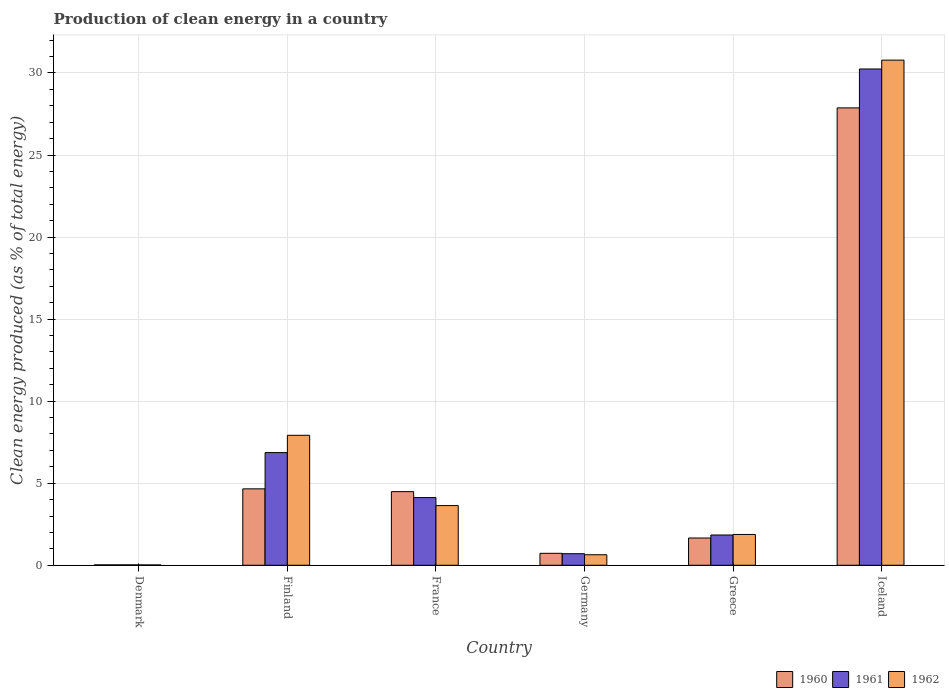How many bars are there on the 4th tick from the right?
Provide a short and direct response. 3. In how many cases, is the number of bars for a given country not equal to the number of legend labels?
Your response must be concise. 0. What is the percentage of clean energy produced in 1961 in Finland?
Offer a very short reply. 6.87. Across all countries, what is the maximum percentage of clean energy produced in 1962?
Provide a succinct answer. 30.78. Across all countries, what is the minimum percentage of clean energy produced in 1962?
Your answer should be very brief. 0.02. In which country was the percentage of clean energy produced in 1962 maximum?
Provide a short and direct response. Iceland. In which country was the percentage of clean energy produced in 1961 minimum?
Your answer should be compact. Denmark. What is the total percentage of clean energy produced in 1960 in the graph?
Your answer should be compact. 39.43. What is the difference between the percentage of clean energy produced in 1962 in Denmark and that in Iceland?
Make the answer very short. -30.76. What is the difference between the percentage of clean energy produced in 1962 in Iceland and the percentage of clean energy produced in 1961 in Finland?
Provide a succinct answer. 23.92. What is the average percentage of clean energy produced in 1960 per country?
Offer a very short reply. 6.57. What is the difference between the percentage of clean energy produced of/in 1962 and percentage of clean energy produced of/in 1960 in Iceland?
Make the answer very short. 2.91. What is the ratio of the percentage of clean energy produced in 1961 in Greece to that in Iceland?
Your response must be concise. 0.06. What is the difference between the highest and the second highest percentage of clean energy produced in 1961?
Your response must be concise. -26.12. What is the difference between the highest and the lowest percentage of clean energy produced in 1961?
Provide a succinct answer. 30.22. In how many countries, is the percentage of clean energy produced in 1962 greater than the average percentage of clean energy produced in 1962 taken over all countries?
Give a very brief answer. 2. Is the sum of the percentage of clean energy produced in 1962 in Denmark and France greater than the maximum percentage of clean energy produced in 1961 across all countries?
Ensure brevity in your answer.  No. What does the 2nd bar from the left in Germany represents?
Keep it short and to the point. 1961. What does the 1st bar from the right in Iceland represents?
Make the answer very short. 1962. Is it the case that in every country, the sum of the percentage of clean energy produced in 1961 and percentage of clean energy produced in 1962 is greater than the percentage of clean energy produced in 1960?
Give a very brief answer. Yes. Are all the bars in the graph horizontal?
Offer a very short reply. No. How many countries are there in the graph?
Give a very brief answer. 6. Does the graph contain any zero values?
Your answer should be very brief. No. Where does the legend appear in the graph?
Offer a terse response. Bottom right. How are the legend labels stacked?
Offer a very short reply. Horizontal. What is the title of the graph?
Make the answer very short. Production of clean energy in a country. Does "2014" appear as one of the legend labels in the graph?
Ensure brevity in your answer.  No. What is the label or title of the X-axis?
Offer a terse response. Country. What is the label or title of the Y-axis?
Your response must be concise. Clean energy produced (as % of total energy). What is the Clean energy produced (as % of total energy) in 1960 in Denmark?
Your answer should be compact. 0.02. What is the Clean energy produced (as % of total energy) in 1961 in Denmark?
Offer a terse response. 0.02. What is the Clean energy produced (as % of total energy) in 1962 in Denmark?
Your answer should be very brief. 0.02. What is the Clean energy produced (as % of total energy) of 1960 in Finland?
Offer a terse response. 4.66. What is the Clean energy produced (as % of total energy) in 1961 in Finland?
Ensure brevity in your answer.  6.87. What is the Clean energy produced (as % of total energy) in 1962 in Finland?
Offer a terse response. 7.92. What is the Clean energy produced (as % of total energy) in 1960 in France?
Ensure brevity in your answer.  4.49. What is the Clean energy produced (as % of total energy) in 1961 in France?
Keep it short and to the point. 4.12. What is the Clean energy produced (as % of total energy) in 1962 in France?
Your answer should be compact. 3.64. What is the Clean energy produced (as % of total energy) of 1960 in Germany?
Offer a very short reply. 0.73. What is the Clean energy produced (as % of total energy) in 1961 in Germany?
Your answer should be compact. 0.7. What is the Clean energy produced (as % of total energy) in 1962 in Germany?
Keep it short and to the point. 0.64. What is the Clean energy produced (as % of total energy) of 1960 in Greece?
Provide a short and direct response. 1.66. What is the Clean energy produced (as % of total energy) in 1961 in Greece?
Your response must be concise. 1.84. What is the Clean energy produced (as % of total energy) in 1962 in Greece?
Provide a short and direct response. 1.88. What is the Clean energy produced (as % of total energy) of 1960 in Iceland?
Provide a succinct answer. 27.87. What is the Clean energy produced (as % of total energy) in 1961 in Iceland?
Offer a very short reply. 30.24. What is the Clean energy produced (as % of total energy) of 1962 in Iceland?
Offer a very short reply. 30.78. Across all countries, what is the maximum Clean energy produced (as % of total energy) of 1960?
Offer a very short reply. 27.87. Across all countries, what is the maximum Clean energy produced (as % of total energy) in 1961?
Make the answer very short. 30.24. Across all countries, what is the maximum Clean energy produced (as % of total energy) of 1962?
Make the answer very short. 30.78. Across all countries, what is the minimum Clean energy produced (as % of total energy) in 1960?
Give a very brief answer. 0.02. Across all countries, what is the minimum Clean energy produced (as % of total energy) in 1961?
Your answer should be very brief. 0.02. Across all countries, what is the minimum Clean energy produced (as % of total energy) in 1962?
Provide a succinct answer. 0.02. What is the total Clean energy produced (as % of total energy) of 1960 in the graph?
Offer a terse response. 39.43. What is the total Clean energy produced (as % of total energy) in 1961 in the graph?
Offer a very short reply. 43.81. What is the total Clean energy produced (as % of total energy) in 1962 in the graph?
Your response must be concise. 44.88. What is the difference between the Clean energy produced (as % of total energy) in 1960 in Denmark and that in Finland?
Make the answer very short. -4.63. What is the difference between the Clean energy produced (as % of total energy) in 1961 in Denmark and that in Finland?
Your answer should be compact. -6.84. What is the difference between the Clean energy produced (as % of total energy) in 1962 in Denmark and that in Finland?
Provide a short and direct response. -7.9. What is the difference between the Clean energy produced (as % of total energy) in 1960 in Denmark and that in France?
Ensure brevity in your answer.  -4.46. What is the difference between the Clean energy produced (as % of total energy) of 1961 in Denmark and that in France?
Offer a very short reply. -4.1. What is the difference between the Clean energy produced (as % of total energy) of 1962 in Denmark and that in France?
Give a very brief answer. -3.62. What is the difference between the Clean energy produced (as % of total energy) in 1960 in Denmark and that in Germany?
Make the answer very short. -0.7. What is the difference between the Clean energy produced (as % of total energy) in 1961 in Denmark and that in Germany?
Your response must be concise. -0.68. What is the difference between the Clean energy produced (as % of total energy) in 1962 in Denmark and that in Germany?
Provide a short and direct response. -0.62. What is the difference between the Clean energy produced (as % of total energy) of 1960 in Denmark and that in Greece?
Provide a succinct answer. -1.64. What is the difference between the Clean energy produced (as % of total energy) of 1961 in Denmark and that in Greece?
Give a very brief answer. -1.82. What is the difference between the Clean energy produced (as % of total energy) of 1962 in Denmark and that in Greece?
Provide a succinct answer. -1.86. What is the difference between the Clean energy produced (as % of total energy) of 1960 in Denmark and that in Iceland?
Provide a succinct answer. -27.85. What is the difference between the Clean energy produced (as % of total energy) of 1961 in Denmark and that in Iceland?
Your answer should be compact. -30.22. What is the difference between the Clean energy produced (as % of total energy) in 1962 in Denmark and that in Iceland?
Give a very brief answer. -30.76. What is the difference between the Clean energy produced (as % of total energy) of 1960 in Finland and that in France?
Your response must be concise. 0.17. What is the difference between the Clean energy produced (as % of total energy) in 1961 in Finland and that in France?
Ensure brevity in your answer.  2.74. What is the difference between the Clean energy produced (as % of total energy) of 1962 in Finland and that in France?
Give a very brief answer. 4.28. What is the difference between the Clean energy produced (as % of total energy) of 1960 in Finland and that in Germany?
Provide a short and direct response. 3.93. What is the difference between the Clean energy produced (as % of total energy) of 1961 in Finland and that in Germany?
Provide a short and direct response. 6.16. What is the difference between the Clean energy produced (as % of total energy) of 1962 in Finland and that in Germany?
Keep it short and to the point. 7.28. What is the difference between the Clean energy produced (as % of total energy) of 1960 in Finland and that in Greece?
Ensure brevity in your answer.  3. What is the difference between the Clean energy produced (as % of total energy) in 1961 in Finland and that in Greece?
Offer a terse response. 5.02. What is the difference between the Clean energy produced (as % of total energy) of 1962 in Finland and that in Greece?
Make the answer very short. 6.04. What is the difference between the Clean energy produced (as % of total energy) of 1960 in Finland and that in Iceland?
Ensure brevity in your answer.  -23.22. What is the difference between the Clean energy produced (as % of total energy) in 1961 in Finland and that in Iceland?
Offer a terse response. -23.38. What is the difference between the Clean energy produced (as % of total energy) of 1962 in Finland and that in Iceland?
Keep it short and to the point. -22.86. What is the difference between the Clean energy produced (as % of total energy) of 1960 in France and that in Germany?
Provide a succinct answer. 3.76. What is the difference between the Clean energy produced (as % of total energy) in 1961 in France and that in Germany?
Your answer should be compact. 3.42. What is the difference between the Clean energy produced (as % of total energy) in 1962 in France and that in Germany?
Your response must be concise. 3. What is the difference between the Clean energy produced (as % of total energy) of 1960 in France and that in Greece?
Offer a terse response. 2.83. What is the difference between the Clean energy produced (as % of total energy) of 1961 in France and that in Greece?
Your answer should be compact. 2.28. What is the difference between the Clean energy produced (as % of total energy) in 1962 in France and that in Greece?
Make the answer very short. 1.76. What is the difference between the Clean energy produced (as % of total energy) of 1960 in France and that in Iceland?
Make the answer very short. -23.39. What is the difference between the Clean energy produced (as % of total energy) in 1961 in France and that in Iceland?
Offer a very short reply. -26.12. What is the difference between the Clean energy produced (as % of total energy) in 1962 in France and that in Iceland?
Ensure brevity in your answer.  -27.15. What is the difference between the Clean energy produced (as % of total energy) in 1960 in Germany and that in Greece?
Your answer should be compact. -0.93. What is the difference between the Clean energy produced (as % of total energy) of 1961 in Germany and that in Greece?
Your answer should be compact. -1.14. What is the difference between the Clean energy produced (as % of total energy) in 1962 in Germany and that in Greece?
Offer a terse response. -1.24. What is the difference between the Clean energy produced (as % of total energy) of 1960 in Germany and that in Iceland?
Your answer should be very brief. -27.14. What is the difference between the Clean energy produced (as % of total energy) of 1961 in Germany and that in Iceland?
Your answer should be very brief. -29.54. What is the difference between the Clean energy produced (as % of total energy) of 1962 in Germany and that in Iceland?
Make the answer very short. -30.14. What is the difference between the Clean energy produced (as % of total energy) in 1960 in Greece and that in Iceland?
Provide a short and direct response. -26.21. What is the difference between the Clean energy produced (as % of total energy) of 1961 in Greece and that in Iceland?
Offer a terse response. -28.4. What is the difference between the Clean energy produced (as % of total energy) of 1962 in Greece and that in Iceland?
Ensure brevity in your answer.  -28.9. What is the difference between the Clean energy produced (as % of total energy) in 1960 in Denmark and the Clean energy produced (as % of total energy) in 1961 in Finland?
Your answer should be very brief. -6.84. What is the difference between the Clean energy produced (as % of total energy) in 1960 in Denmark and the Clean energy produced (as % of total energy) in 1962 in Finland?
Provide a short and direct response. -7.9. What is the difference between the Clean energy produced (as % of total energy) in 1961 in Denmark and the Clean energy produced (as % of total energy) in 1962 in Finland?
Your answer should be very brief. -7.9. What is the difference between the Clean energy produced (as % of total energy) in 1960 in Denmark and the Clean energy produced (as % of total energy) in 1962 in France?
Your answer should be compact. -3.61. What is the difference between the Clean energy produced (as % of total energy) of 1961 in Denmark and the Clean energy produced (as % of total energy) of 1962 in France?
Offer a terse response. -3.61. What is the difference between the Clean energy produced (as % of total energy) in 1960 in Denmark and the Clean energy produced (as % of total energy) in 1961 in Germany?
Ensure brevity in your answer.  -0.68. What is the difference between the Clean energy produced (as % of total energy) of 1960 in Denmark and the Clean energy produced (as % of total energy) of 1962 in Germany?
Your response must be concise. -0.62. What is the difference between the Clean energy produced (as % of total energy) of 1961 in Denmark and the Clean energy produced (as % of total energy) of 1962 in Germany?
Provide a short and direct response. -0.62. What is the difference between the Clean energy produced (as % of total energy) in 1960 in Denmark and the Clean energy produced (as % of total energy) in 1961 in Greece?
Offer a very short reply. -1.82. What is the difference between the Clean energy produced (as % of total energy) in 1960 in Denmark and the Clean energy produced (as % of total energy) in 1962 in Greece?
Offer a terse response. -1.85. What is the difference between the Clean energy produced (as % of total energy) in 1961 in Denmark and the Clean energy produced (as % of total energy) in 1962 in Greece?
Offer a terse response. -1.85. What is the difference between the Clean energy produced (as % of total energy) of 1960 in Denmark and the Clean energy produced (as % of total energy) of 1961 in Iceland?
Provide a succinct answer. -30.22. What is the difference between the Clean energy produced (as % of total energy) in 1960 in Denmark and the Clean energy produced (as % of total energy) in 1962 in Iceland?
Your answer should be compact. -30.76. What is the difference between the Clean energy produced (as % of total energy) in 1961 in Denmark and the Clean energy produced (as % of total energy) in 1962 in Iceland?
Your response must be concise. -30.76. What is the difference between the Clean energy produced (as % of total energy) in 1960 in Finland and the Clean energy produced (as % of total energy) in 1961 in France?
Offer a very short reply. 0.53. What is the difference between the Clean energy produced (as % of total energy) in 1960 in Finland and the Clean energy produced (as % of total energy) in 1962 in France?
Give a very brief answer. 1.02. What is the difference between the Clean energy produced (as % of total energy) in 1961 in Finland and the Clean energy produced (as % of total energy) in 1962 in France?
Ensure brevity in your answer.  3.23. What is the difference between the Clean energy produced (as % of total energy) in 1960 in Finland and the Clean energy produced (as % of total energy) in 1961 in Germany?
Your answer should be compact. 3.95. What is the difference between the Clean energy produced (as % of total energy) in 1960 in Finland and the Clean energy produced (as % of total energy) in 1962 in Germany?
Offer a terse response. 4.02. What is the difference between the Clean energy produced (as % of total energy) in 1961 in Finland and the Clean energy produced (as % of total energy) in 1962 in Germany?
Your answer should be compact. 6.23. What is the difference between the Clean energy produced (as % of total energy) in 1960 in Finland and the Clean energy produced (as % of total energy) in 1961 in Greece?
Provide a succinct answer. 2.81. What is the difference between the Clean energy produced (as % of total energy) in 1960 in Finland and the Clean energy produced (as % of total energy) in 1962 in Greece?
Give a very brief answer. 2.78. What is the difference between the Clean energy produced (as % of total energy) in 1961 in Finland and the Clean energy produced (as % of total energy) in 1962 in Greece?
Your answer should be compact. 4.99. What is the difference between the Clean energy produced (as % of total energy) in 1960 in Finland and the Clean energy produced (as % of total energy) in 1961 in Iceland?
Provide a succinct answer. -25.59. What is the difference between the Clean energy produced (as % of total energy) of 1960 in Finland and the Clean energy produced (as % of total energy) of 1962 in Iceland?
Make the answer very short. -26.13. What is the difference between the Clean energy produced (as % of total energy) of 1961 in Finland and the Clean energy produced (as % of total energy) of 1962 in Iceland?
Give a very brief answer. -23.92. What is the difference between the Clean energy produced (as % of total energy) of 1960 in France and the Clean energy produced (as % of total energy) of 1961 in Germany?
Offer a terse response. 3.78. What is the difference between the Clean energy produced (as % of total energy) of 1960 in France and the Clean energy produced (as % of total energy) of 1962 in Germany?
Give a very brief answer. 3.85. What is the difference between the Clean energy produced (as % of total energy) of 1961 in France and the Clean energy produced (as % of total energy) of 1962 in Germany?
Offer a very short reply. 3.48. What is the difference between the Clean energy produced (as % of total energy) in 1960 in France and the Clean energy produced (as % of total energy) in 1961 in Greece?
Give a very brief answer. 2.64. What is the difference between the Clean energy produced (as % of total energy) in 1960 in France and the Clean energy produced (as % of total energy) in 1962 in Greece?
Provide a short and direct response. 2.61. What is the difference between the Clean energy produced (as % of total energy) in 1961 in France and the Clean energy produced (as % of total energy) in 1962 in Greece?
Your answer should be very brief. 2.25. What is the difference between the Clean energy produced (as % of total energy) in 1960 in France and the Clean energy produced (as % of total energy) in 1961 in Iceland?
Provide a succinct answer. -25.76. What is the difference between the Clean energy produced (as % of total energy) of 1960 in France and the Clean energy produced (as % of total energy) of 1962 in Iceland?
Provide a succinct answer. -26.3. What is the difference between the Clean energy produced (as % of total energy) of 1961 in France and the Clean energy produced (as % of total energy) of 1962 in Iceland?
Provide a succinct answer. -26.66. What is the difference between the Clean energy produced (as % of total energy) of 1960 in Germany and the Clean energy produced (as % of total energy) of 1961 in Greece?
Your answer should be compact. -1.12. What is the difference between the Clean energy produced (as % of total energy) of 1960 in Germany and the Clean energy produced (as % of total energy) of 1962 in Greece?
Your answer should be very brief. -1.15. What is the difference between the Clean energy produced (as % of total energy) of 1961 in Germany and the Clean energy produced (as % of total energy) of 1962 in Greece?
Ensure brevity in your answer.  -1.17. What is the difference between the Clean energy produced (as % of total energy) of 1960 in Germany and the Clean energy produced (as % of total energy) of 1961 in Iceland?
Offer a very short reply. -29.52. What is the difference between the Clean energy produced (as % of total energy) in 1960 in Germany and the Clean energy produced (as % of total energy) in 1962 in Iceland?
Your response must be concise. -30.05. What is the difference between the Clean energy produced (as % of total energy) of 1961 in Germany and the Clean energy produced (as % of total energy) of 1962 in Iceland?
Keep it short and to the point. -30.08. What is the difference between the Clean energy produced (as % of total energy) of 1960 in Greece and the Clean energy produced (as % of total energy) of 1961 in Iceland?
Ensure brevity in your answer.  -28.58. What is the difference between the Clean energy produced (as % of total energy) in 1960 in Greece and the Clean energy produced (as % of total energy) in 1962 in Iceland?
Provide a short and direct response. -29.12. What is the difference between the Clean energy produced (as % of total energy) in 1961 in Greece and the Clean energy produced (as % of total energy) in 1962 in Iceland?
Your answer should be compact. -28.94. What is the average Clean energy produced (as % of total energy) in 1960 per country?
Make the answer very short. 6.57. What is the average Clean energy produced (as % of total energy) in 1961 per country?
Provide a short and direct response. 7.3. What is the average Clean energy produced (as % of total energy) in 1962 per country?
Keep it short and to the point. 7.48. What is the difference between the Clean energy produced (as % of total energy) of 1960 and Clean energy produced (as % of total energy) of 1962 in Denmark?
Give a very brief answer. 0. What is the difference between the Clean energy produced (as % of total energy) of 1961 and Clean energy produced (as % of total energy) of 1962 in Denmark?
Give a very brief answer. 0. What is the difference between the Clean energy produced (as % of total energy) of 1960 and Clean energy produced (as % of total energy) of 1961 in Finland?
Keep it short and to the point. -2.21. What is the difference between the Clean energy produced (as % of total energy) in 1960 and Clean energy produced (as % of total energy) in 1962 in Finland?
Offer a terse response. -3.26. What is the difference between the Clean energy produced (as % of total energy) in 1961 and Clean energy produced (as % of total energy) in 1962 in Finland?
Keep it short and to the point. -1.06. What is the difference between the Clean energy produced (as % of total energy) of 1960 and Clean energy produced (as % of total energy) of 1961 in France?
Make the answer very short. 0.36. What is the difference between the Clean energy produced (as % of total energy) of 1960 and Clean energy produced (as % of total energy) of 1962 in France?
Offer a terse response. 0.85. What is the difference between the Clean energy produced (as % of total energy) in 1961 and Clean energy produced (as % of total energy) in 1962 in France?
Your answer should be very brief. 0.49. What is the difference between the Clean energy produced (as % of total energy) in 1960 and Clean energy produced (as % of total energy) in 1961 in Germany?
Your answer should be compact. 0.02. What is the difference between the Clean energy produced (as % of total energy) of 1960 and Clean energy produced (as % of total energy) of 1962 in Germany?
Your answer should be very brief. 0.09. What is the difference between the Clean energy produced (as % of total energy) in 1961 and Clean energy produced (as % of total energy) in 1962 in Germany?
Offer a terse response. 0.06. What is the difference between the Clean energy produced (as % of total energy) of 1960 and Clean energy produced (as % of total energy) of 1961 in Greece?
Offer a terse response. -0.18. What is the difference between the Clean energy produced (as % of total energy) of 1960 and Clean energy produced (as % of total energy) of 1962 in Greece?
Give a very brief answer. -0.22. What is the difference between the Clean energy produced (as % of total energy) of 1961 and Clean energy produced (as % of total energy) of 1962 in Greece?
Offer a very short reply. -0.03. What is the difference between the Clean energy produced (as % of total energy) in 1960 and Clean energy produced (as % of total energy) in 1961 in Iceland?
Ensure brevity in your answer.  -2.37. What is the difference between the Clean energy produced (as % of total energy) of 1960 and Clean energy produced (as % of total energy) of 1962 in Iceland?
Offer a very short reply. -2.91. What is the difference between the Clean energy produced (as % of total energy) of 1961 and Clean energy produced (as % of total energy) of 1962 in Iceland?
Provide a succinct answer. -0.54. What is the ratio of the Clean energy produced (as % of total energy) of 1960 in Denmark to that in Finland?
Offer a very short reply. 0.01. What is the ratio of the Clean energy produced (as % of total energy) of 1961 in Denmark to that in Finland?
Ensure brevity in your answer.  0. What is the ratio of the Clean energy produced (as % of total energy) of 1962 in Denmark to that in Finland?
Your answer should be very brief. 0. What is the ratio of the Clean energy produced (as % of total energy) in 1960 in Denmark to that in France?
Provide a short and direct response. 0.01. What is the ratio of the Clean energy produced (as % of total energy) in 1961 in Denmark to that in France?
Ensure brevity in your answer.  0.01. What is the ratio of the Clean energy produced (as % of total energy) in 1962 in Denmark to that in France?
Provide a succinct answer. 0.01. What is the ratio of the Clean energy produced (as % of total energy) of 1960 in Denmark to that in Germany?
Your answer should be very brief. 0.03. What is the ratio of the Clean energy produced (as % of total energy) of 1961 in Denmark to that in Germany?
Give a very brief answer. 0.03. What is the ratio of the Clean energy produced (as % of total energy) of 1962 in Denmark to that in Germany?
Your answer should be compact. 0.03. What is the ratio of the Clean energy produced (as % of total energy) of 1960 in Denmark to that in Greece?
Keep it short and to the point. 0.01. What is the ratio of the Clean energy produced (as % of total energy) of 1961 in Denmark to that in Greece?
Keep it short and to the point. 0.01. What is the ratio of the Clean energy produced (as % of total energy) in 1962 in Denmark to that in Greece?
Keep it short and to the point. 0.01. What is the ratio of the Clean energy produced (as % of total energy) in 1960 in Denmark to that in Iceland?
Ensure brevity in your answer.  0. What is the ratio of the Clean energy produced (as % of total energy) of 1961 in Denmark to that in Iceland?
Your answer should be compact. 0. What is the ratio of the Clean energy produced (as % of total energy) in 1962 in Denmark to that in Iceland?
Keep it short and to the point. 0. What is the ratio of the Clean energy produced (as % of total energy) of 1960 in Finland to that in France?
Offer a very short reply. 1.04. What is the ratio of the Clean energy produced (as % of total energy) in 1961 in Finland to that in France?
Offer a very short reply. 1.66. What is the ratio of the Clean energy produced (as % of total energy) of 1962 in Finland to that in France?
Give a very brief answer. 2.18. What is the ratio of the Clean energy produced (as % of total energy) in 1960 in Finland to that in Germany?
Keep it short and to the point. 6.4. What is the ratio of the Clean energy produced (as % of total energy) in 1961 in Finland to that in Germany?
Offer a terse response. 9.74. What is the ratio of the Clean energy produced (as % of total energy) of 1962 in Finland to that in Germany?
Provide a short and direct response. 12.37. What is the ratio of the Clean energy produced (as % of total energy) in 1960 in Finland to that in Greece?
Give a very brief answer. 2.8. What is the ratio of the Clean energy produced (as % of total energy) in 1961 in Finland to that in Greece?
Keep it short and to the point. 3.72. What is the ratio of the Clean energy produced (as % of total energy) in 1962 in Finland to that in Greece?
Offer a terse response. 4.22. What is the ratio of the Clean energy produced (as % of total energy) of 1960 in Finland to that in Iceland?
Keep it short and to the point. 0.17. What is the ratio of the Clean energy produced (as % of total energy) in 1961 in Finland to that in Iceland?
Your answer should be very brief. 0.23. What is the ratio of the Clean energy produced (as % of total energy) of 1962 in Finland to that in Iceland?
Provide a succinct answer. 0.26. What is the ratio of the Clean energy produced (as % of total energy) of 1960 in France to that in Germany?
Offer a terse response. 6.16. What is the ratio of the Clean energy produced (as % of total energy) of 1961 in France to that in Germany?
Make the answer very short. 5.85. What is the ratio of the Clean energy produced (as % of total energy) in 1962 in France to that in Germany?
Offer a very short reply. 5.68. What is the ratio of the Clean energy produced (as % of total energy) in 1960 in France to that in Greece?
Give a very brief answer. 2.7. What is the ratio of the Clean energy produced (as % of total energy) in 1961 in France to that in Greece?
Give a very brief answer. 2.24. What is the ratio of the Clean energy produced (as % of total energy) of 1962 in France to that in Greece?
Provide a succinct answer. 1.94. What is the ratio of the Clean energy produced (as % of total energy) of 1960 in France to that in Iceland?
Give a very brief answer. 0.16. What is the ratio of the Clean energy produced (as % of total energy) in 1961 in France to that in Iceland?
Make the answer very short. 0.14. What is the ratio of the Clean energy produced (as % of total energy) of 1962 in France to that in Iceland?
Give a very brief answer. 0.12. What is the ratio of the Clean energy produced (as % of total energy) of 1960 in Germany to that in Greece?
Give a very brief answer. 0.44. What is the ratio of the Clean energy produced (as % of total energy) of 1961 in Germany to that in Greece?
Provide a short and direct response. 0.38. What is the ratio of the Clean energy produced (as % of total energy) in 1962 in Germany to that in Greece?
Provide a succinct answer. 0.34. What is the ratio of the Clean energy produced (as % of total energy) in 1960 in Germany to that in Iceland?
Your answer should be very brief. 0.03. What is the ratio of the Clean energy produced (as % of total energy) in 1961 in Germany to that in Iceland?
Provide a succinct answer. 0.02. What is the ratio of the Clean energy produced (as % of total energy) in 1962 in Germany to that in Iceland?
Make the answer very short. 0.02. What is the ratio of the Clean energy produced (as % of total energy) of 1960 in Greece to that in Iceland?
Make the answer very short. 0.06. What is the ratio of the Clean energy produced (as % of total energy) in 1961 in Greece to that in Iceland?
Provide a succinct answer. 0.06. What is the ratio of the Clean energy produced (as % of total energy) in 1962 in Greece to that in Iceland?
Ensure brevity in your answer.  0.06. What is the difference between the highest and the second highest Clean energy produced (as % of total energy) of 1960?
Offer a terse response. 23.22. What is the difference between the highest and the second highest Clean energy produced (as % of total energy) of 1961?
Provide a succinct answer. 23.38. What is the difference between the highest and the second highest Clean energy produced (as % of total energy) of 1962?
Ensure brevity in your answer.  22.86. What is the difference between the highest and the lowest Clean energy produced (as % of total energy) of 1960?
Give a very brief answer. 27.85. What is the difference between the highest and the lowest Clean energy produced (as % of total energy) in 1961?
Your answer should be very brief. 30.22. What is the difference between the highest and the lowest Clean energy produced (as % of total energy) of 1962?
Give a very brief answer. 30.76. 